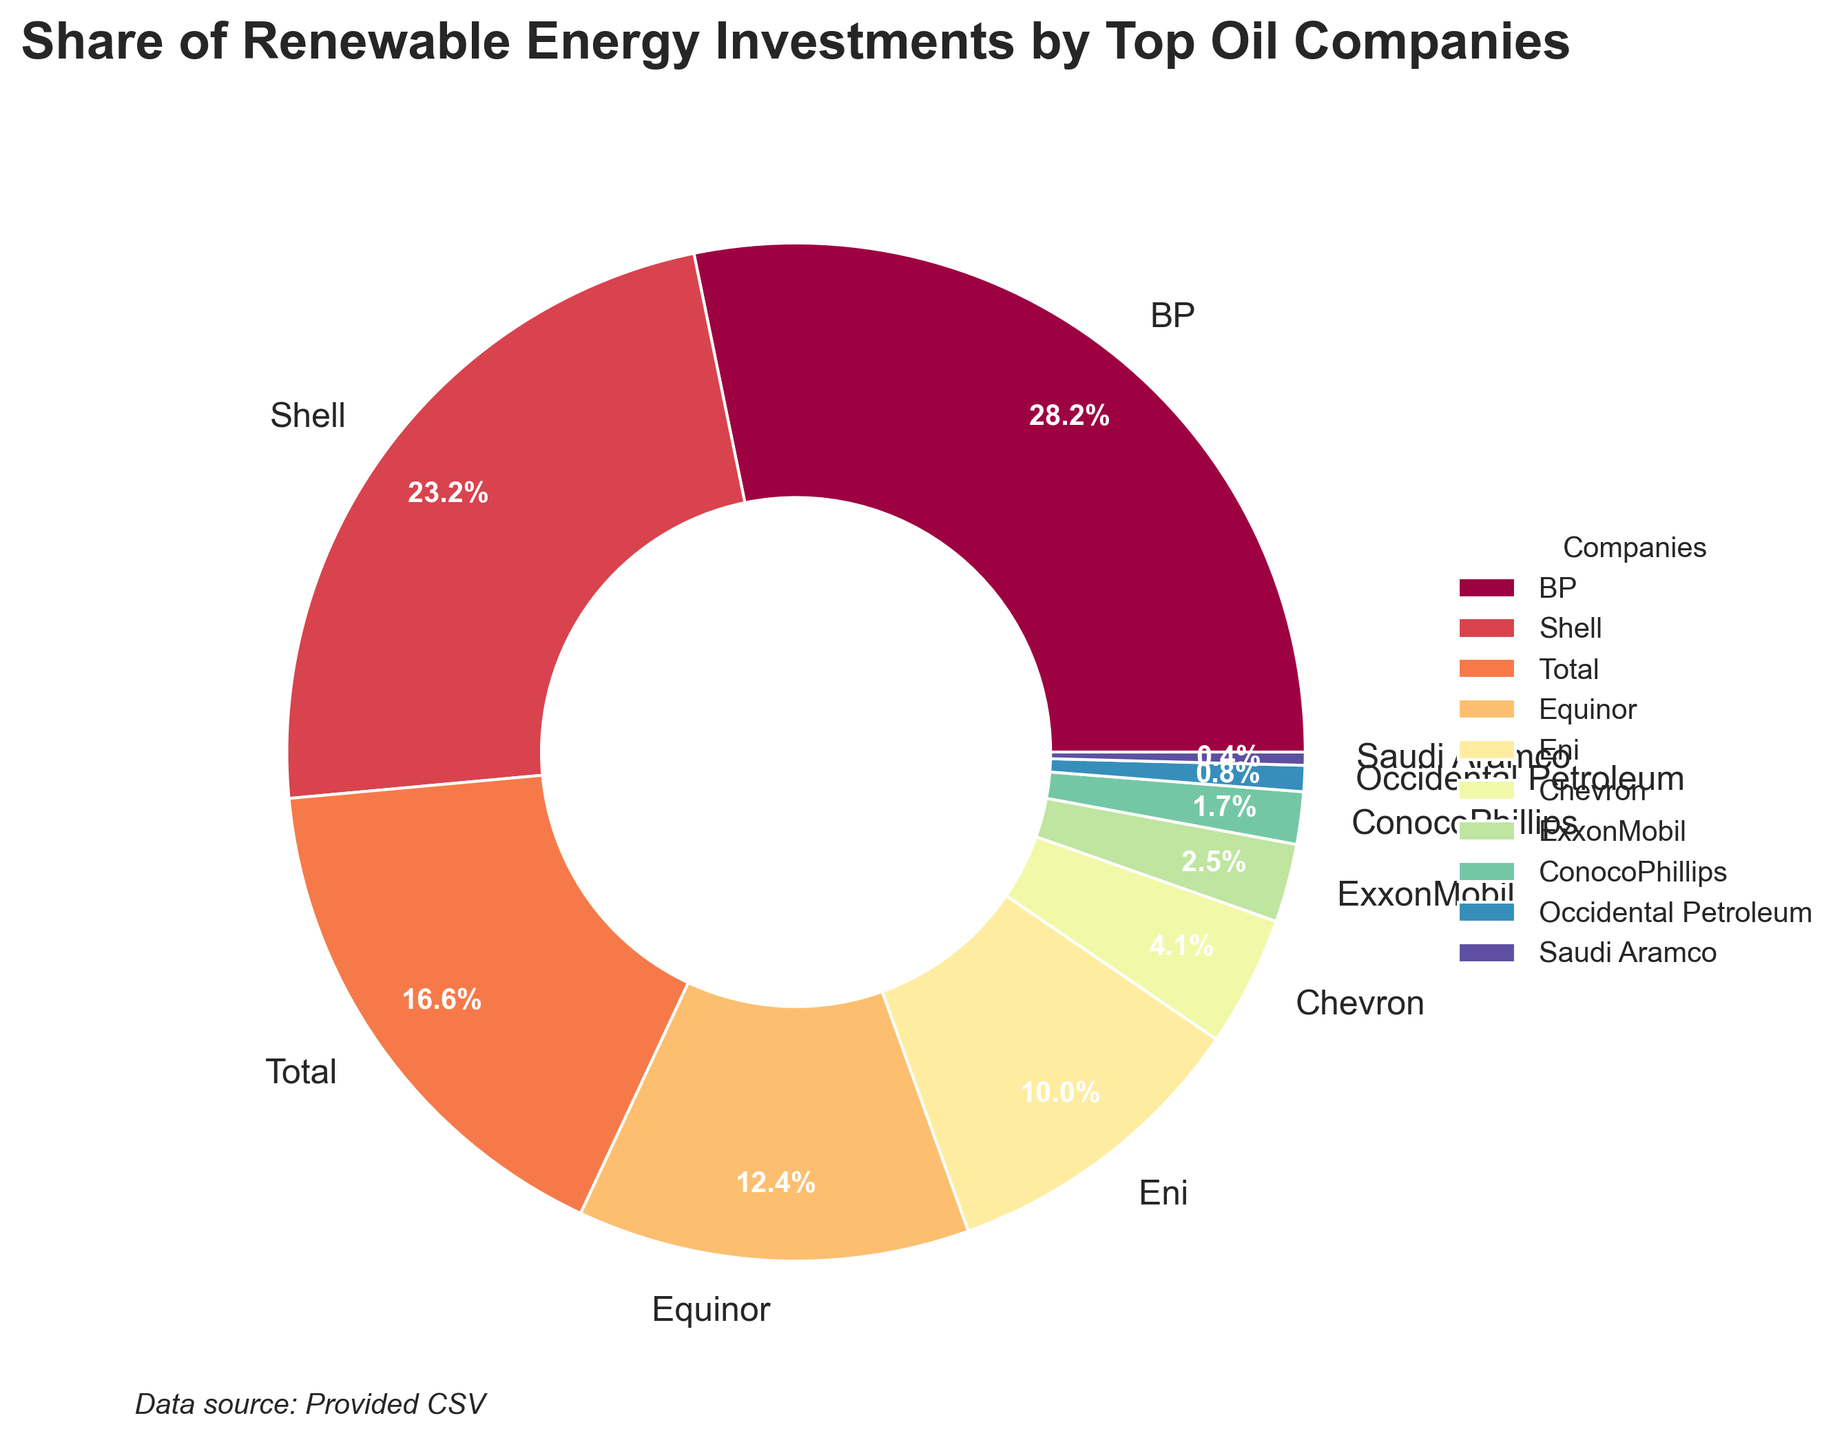Which company invests the most in renewable energy? BP has the highest share of renewable energy investments as represented by the largest segment in the pie chart.
Answer: BP Which two companies combined have a share of renewable energy investments greater than Shell? The companies to consider are those ranked after Shell. Total (20%) and Equinor (15%) combined share is 35%, which is greater than Shell’s 28%.
Answer: Total and Equinor Which company has the smallest share of renewable energy investments? The pie chart shows that Saudi Aramco has the smallest segment, representing 0.5%.
Answer: Saudi Aramco What is the combined share of renewable energy investments of companies ranked 5th and 6th in the list? Eni (12%) and Chevron (5%) are 5th and 6th respectively. The combined share is 12% + 5% = 17%.
Answer: 17% Are there any companies with a share of renewable energy investments less than 3%? Yes, the pie chart shows that ConocoPhillips (2%), Occidental Petroleum (1%), and Saudi Aramco (0.5%) all have shares less than 3%.
Answer: Yes What is the total share of renewable energy investments by the top three companies? The shares of BP (34%), Shell (28%), and Total (20%) sum up to 34% + 28% + 20% = 82%.
Answer: 82% Which company has a share of renewable energy investments exactly twice that of ConocoPhillips? ConocoPhillips has 2%. ExxonMobil, with 3%, is not exactly twice. No company has exactly 4%.
Answer: None How does the share of renewable energy investments for ExxonMobil compare to that of Chevron? Comparing the pie chart segments, Chevron (5%) has a greater share than ExxonMobil (3%).
Answer: Chevron has a greater share What is the average share of renewable energy investments for the listed companies? The sum of the shares is 34 + 28 + 20 + 15 + 12 + 5 + 3 + 2 + 1 + 0.5 = 120.5. The number of companies is 10. The average share is 120.5 / 10 = 12.05%.
Answer: 12.05% What percentage of companies have a share of renewable energy investments of 5% or more? Out of the 10 listed companies, the ones with 5% or more are BP, Shell, Total, Equinor, and Eni. This amounts to 5 companies, which is 50%.
Answer: 50% 